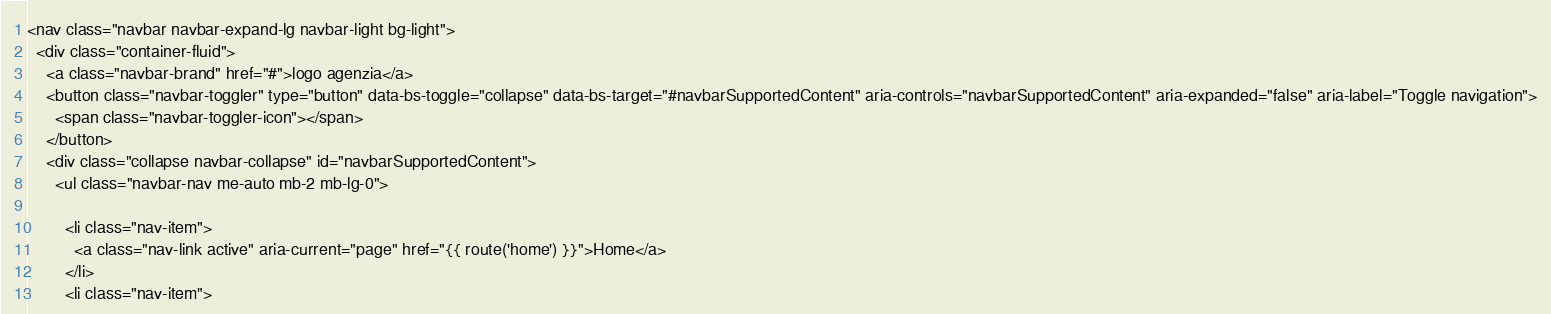Convert code to text. <code><loc_0><loc_0><loc_500><loc_500><_PHP_><nav class="navbar navbar-expand-lg navbar-light bg-light">
  <div class="container-fluid">
    <a class="navbar-brand" href="#">logo agenzia</a>
    <button class="navbar-toggler" type="button" data-bs-toggle="collapse" data-bs-target="#navbarSupportedContent" aria-controls="navbarSupportedContent" aria-expanded="false" aria-label="Toggle navigation">
      <span class="navbar-toggler-icon"></span>
    </button>
    <div class="collapse navbar-collapse" id="navbarSupportedContent">
      <ul class="navbar-nav me-auto mb-2 mb-lg-0">
        
        <li class="nav-item">
          <a class="nav-link active" aria-current="page" href="{{ route('home') }}">Home</a>
        </li>
        <li class="nav-item"></code> 